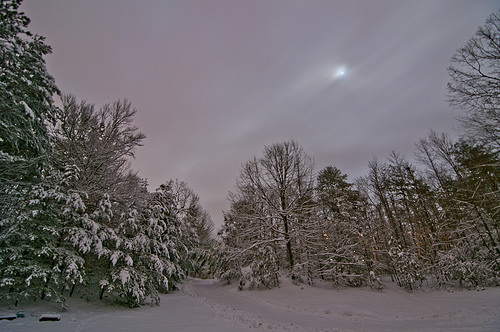<image>
Is there a tree to the right of the tree? No. The tree is not to the right of the tree. The horizontal positioning shows a different relationship. 